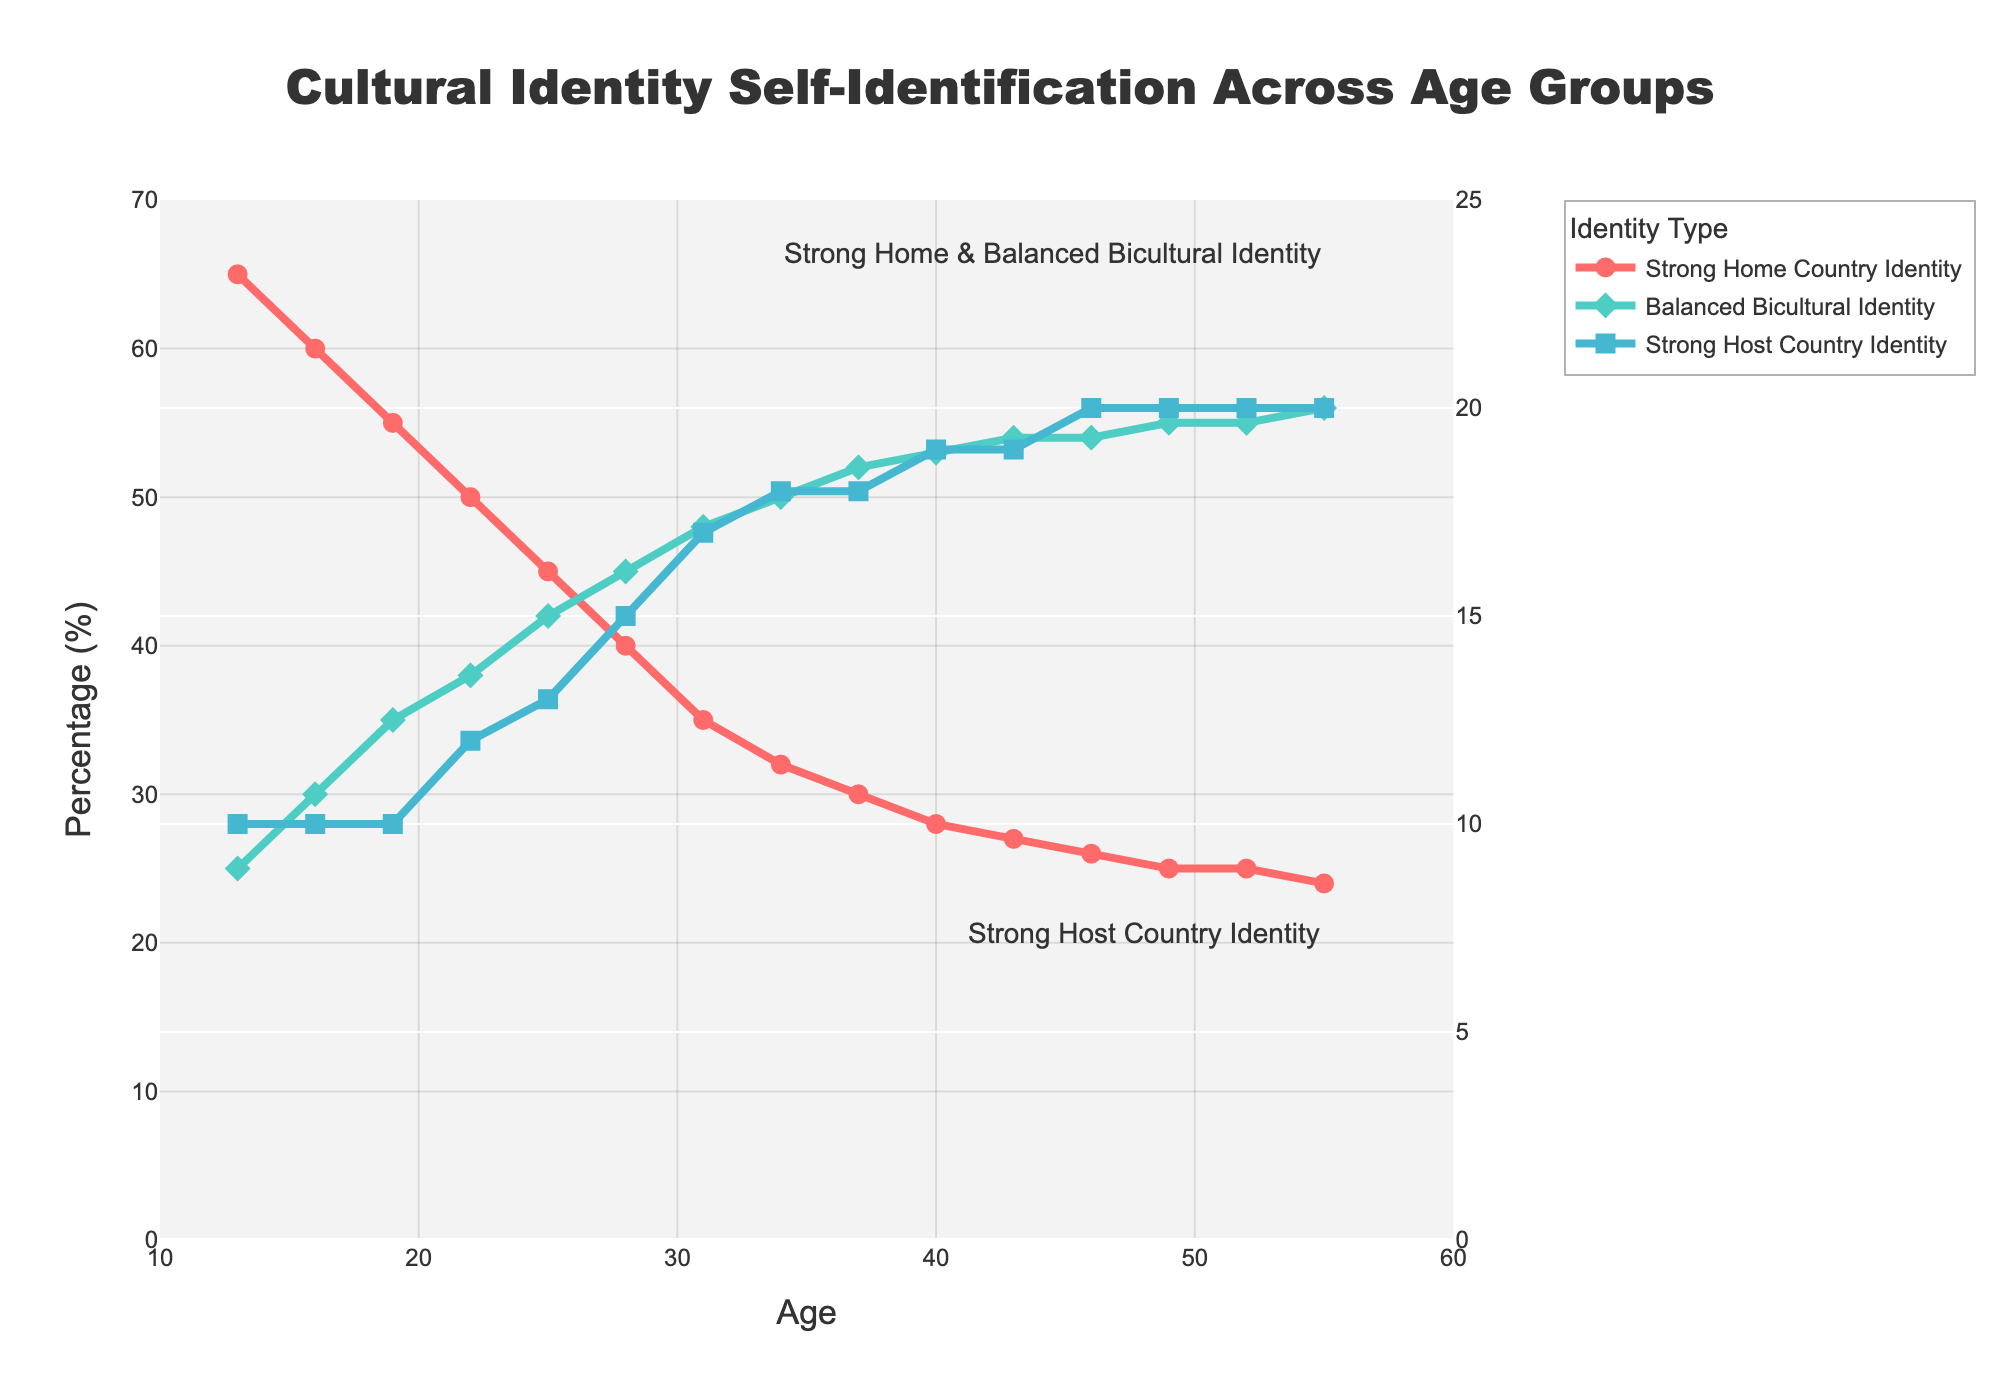What age group shows the highest percentage of individuals with a strong home country identity? To find the highest percentage, look at the values for "Strong Home Country Identity" across all age groups and identify the maximum percentage.
Answer: 13 At what age does the balanced bicultural identity surpass 40%? Check the "Balanced Bicultural Identity" values and see when it first exceeds 40%.
Answer: 28 Did the strong host country identity ever reach 20% before the age of 40? Examine the "Strong Host Country Identity" values for ages less than 40 to determine if it ever reaches 20%. It first hits 19% at age 37 and reaches 20% only at 46.
Answer: No What's the difference in the percentage of strong home country identity between ages 13 and 34? Subtract the percentage at age 34 from that at age 13 for "Strong Home Country Identity" (65 - 32).
Answer: 33 Between what ages does the strong home country identity percentage drop below 50%? Identify age values where "Strong Home Country Identity" is below 50% and find the age range. It first drops below 50% at age 22.
Answer: Between ages 22 and 55 Which identity type has the most stable trend in terms of percentage change across the age groups shown? Review the trends for all identity types and identify the one with the least variation.
Answer: Strong Host Country Identity At what age does the strong home country identity and balanced bicultural identity first have the same percentage value? Compare the values for "Strong Home Country Identity" and "Balanced Bicultural Identity" across all ages to find the point of intersection.
Answer: 52 How does the percentage of balanced bicultural identity change between ages 25 and 40? Calculate the percentage increase/decrease by comparing values at ages 25 and 40 (53 - 42).
Answer: Increases by 11% What is the visual marker used to represent "Balanced Bicultural Identity" in the chart? Identify the visual marker by observing the chart's graphical representation for "Balanced Bicultural Identity".
Answer: Diamond Compare the percentage of strong home country identity at age 19 with the balanced bicultural identity at the same age. Which is higher? Look at the percentages for both identities at age 19 and compare them (55 for Strong Home Country Identity and 35 for Balanced Bicultural Identity).
Answer: Strong Home Country Identity 